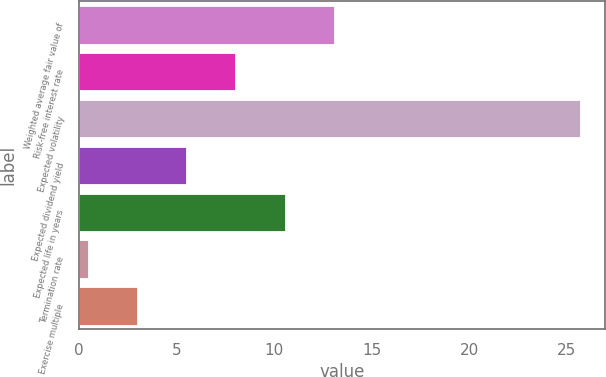Convert chart. <chart><loc_0><loc_0><loc_500><loc_500><bar_chart><fcel>Weighted average fair value of<fcel>Risk-free interest rate<fcel>Expected volatility<fcel>Expected dividend yield<fcel>Expected life in years<fcel>Termination rate<fcel>Exercise multiple<nl><fcel>13.06<fcel>8.02<fcel>25.7<fcel>5.5<fcel>10.54<fcel>0.46<fcel>2.98<nl></chart> 